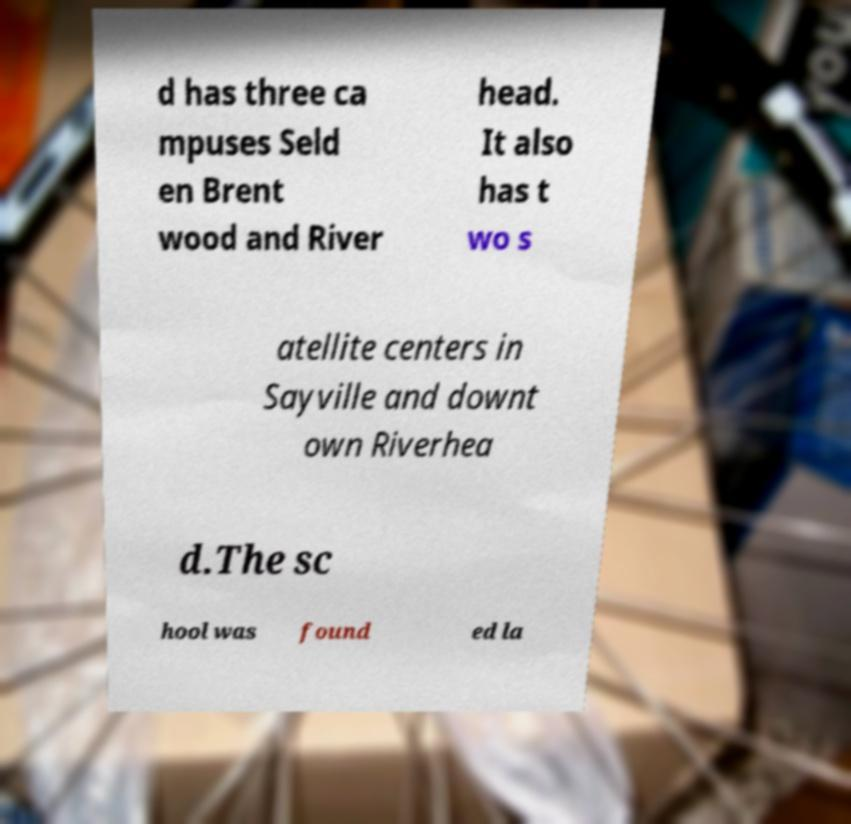Could you assist in decoding the text presented in this image and type it out clearly? d has three ca mpuses Seld en Brent wood and River head. It also has t wo s atellite centers in Sayville and downt own Riverhea d.The sc hool was found ed la 